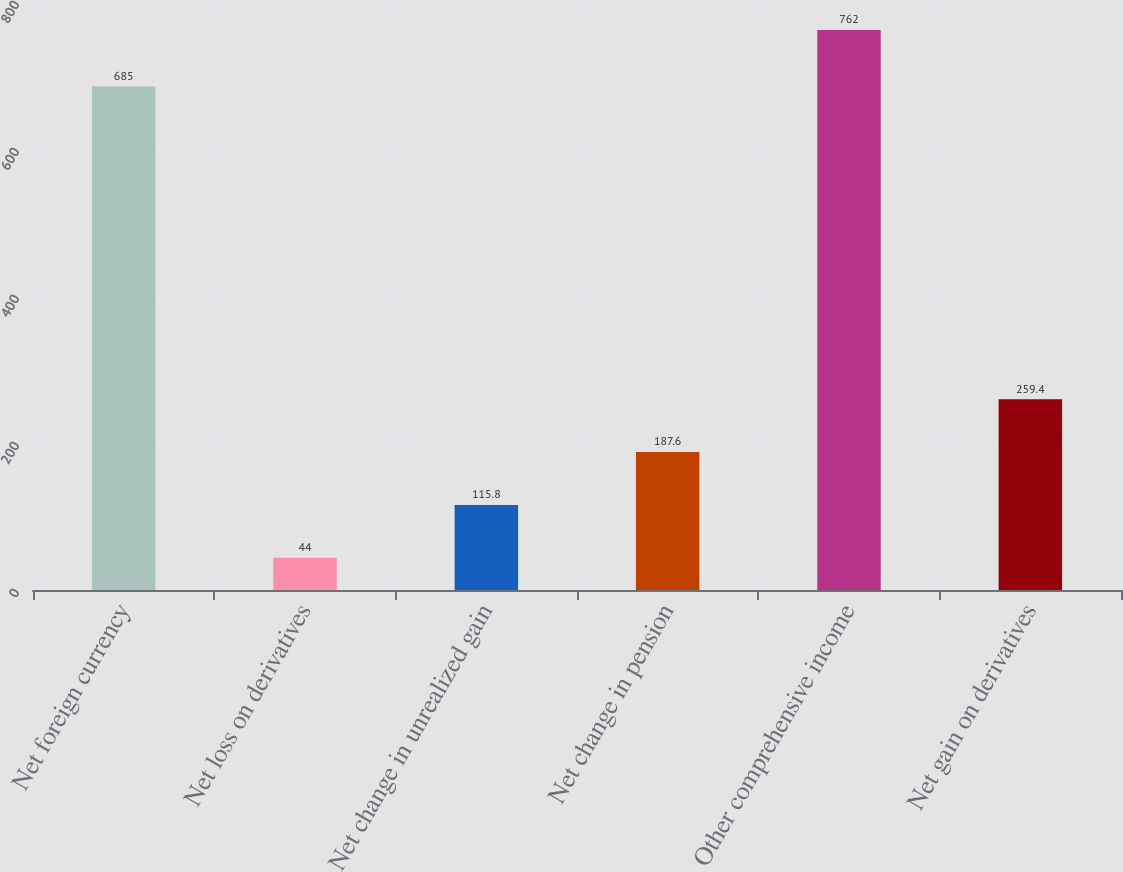Convert chart. <chart><loc_0><loc_0><loc_500><loc_500><bar_chart><fcel>Net foreign currency<fcel>Net loss on derivatives<fcel>Net change in unrealized gain<fcel>Net change in pension<fcel>Other comprehensive income<fcel>Net gain on derivatives<nl><fcel>685<fcel>44<fcel>115.8<fcel>187.6<fcel>762<fcel>259.4<nl></chart> 